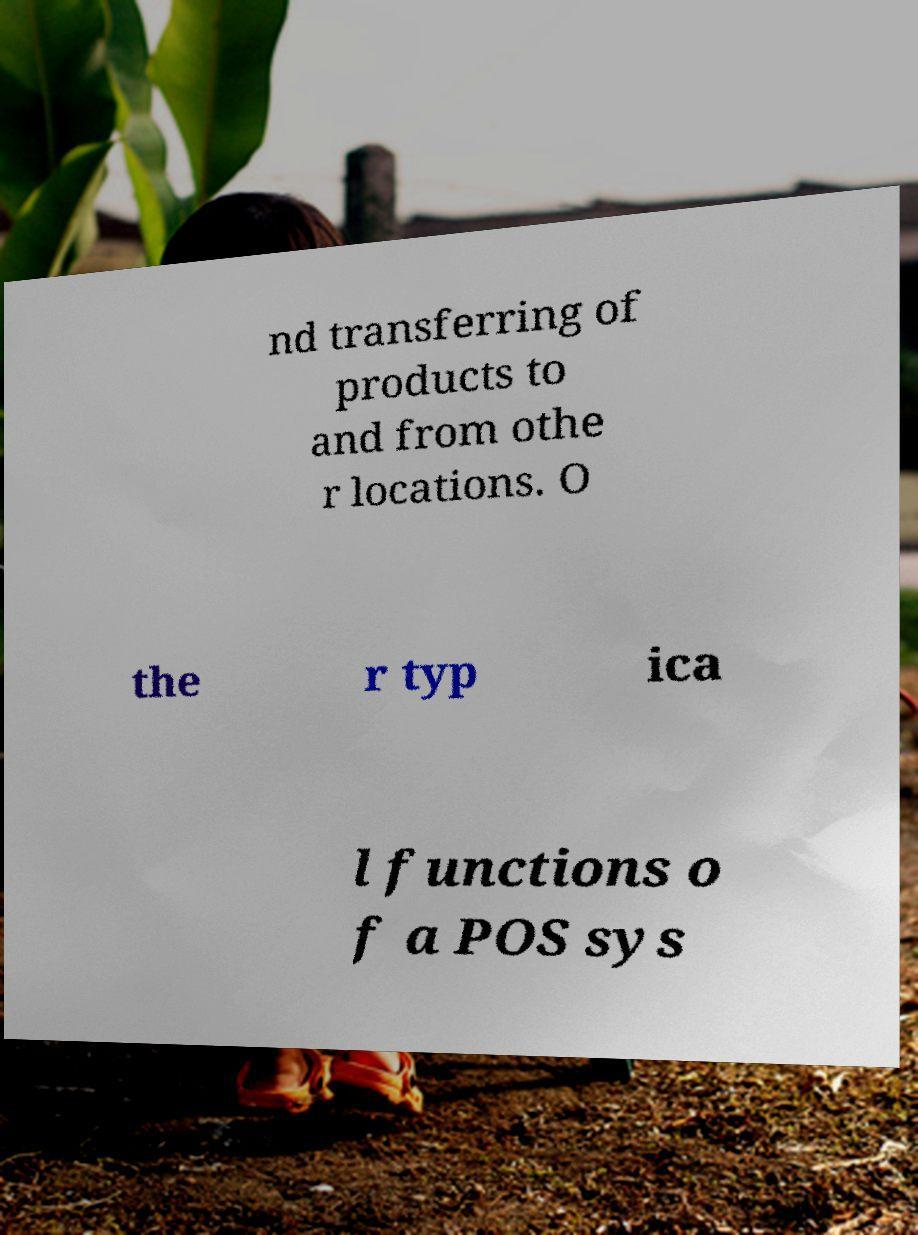Please read and relay the text visible in this image. What does it say? nd transferring of products to and from othe r locations. O the r typ ica l functions o f a POS sys 